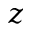<formula> <loc_0><loc_0><loc_500><loc_500>z</formula> 